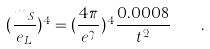<formula> <loc_0><loc_0><loc_500><loc_500>( \frac { m _ { S } } { e _ { L } } ) ^ { 4 } = ( \frac { 4 \pi } { e ^ { \gamma } } ) ^ { 4 } \frac { 0 . 0 0 0 8 } { t ^ { 2 } } \quad .</formula> 